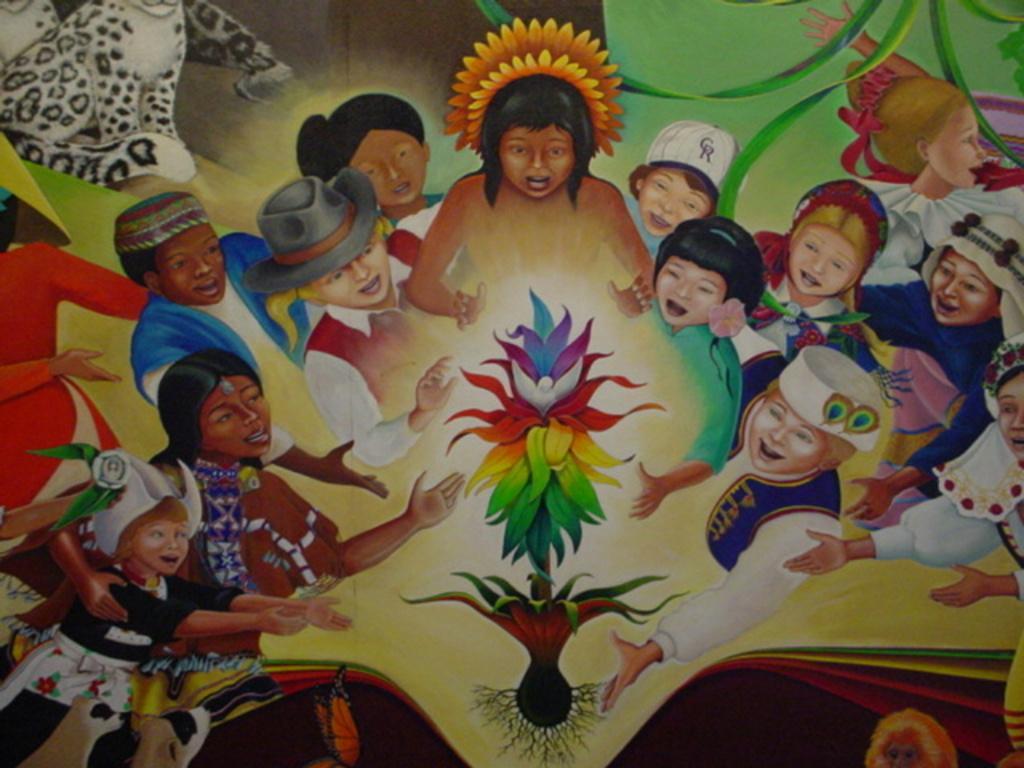How would you summarize this image in a sentence or two? In this image I can see few paintings of few persons. In front I can see flowers in multi color and the persons are wearing different color dresses. Background the wall is in green and brown color. 